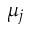<formula> <loc_0><loc_0><loc_500><loc_500>\mu _ { j }</formula> 